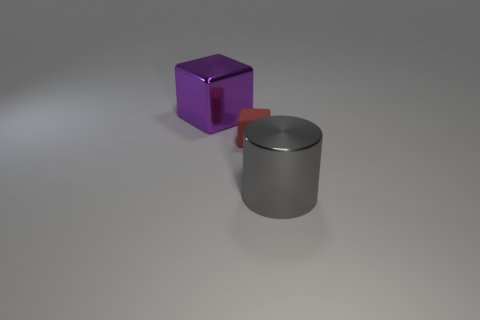What material is the large object to the right of the large thing behind the tiny rubber object?
Your answer should be very brief. Metal. Do the large thing that is on the left side of the big gray metal thing and the red block have the same material?
Your answer should be very brief. No. There is a red rubber block that is in front of the large purple cube; what is its size?
Your response must be concise. Small. Is there a big metal object that is in front of the purple thing left of the large gray metallic object?
Your answer should be very brief. Yes. The metallic cylinder is what color?
Keep it short and to the point. Gray. There is a thing that is both right of the big purple object and behind the large cylinder; what is its color?
Offer a very short reply. Red. There is a red block that is behind the shiny cylinder; is it the same size as the big purple metallic object?
Offer a very short reply. No. Are there more small rubber things that are on the right side of the purple metal object than small blue rubber objects?
Give a very brief answer. Yes. Is the shape of the big purple thing the same as the red matte object?
Offer a very short reply. Yes. The gray cylinder has what size?
Ensure brevity in your answer.  Large. 